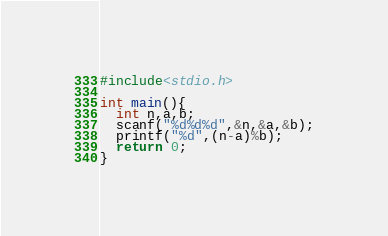Convert code to text. <code><loc_0><loc_0><loc_500><loc_500><_C_>#include<stdio.h>

int main(){
  int n,a,b;
  scanf("%d%d%d",&n,&a,&b);
  printf("%d",(n-a)%b);
  return 0;
}</code> 